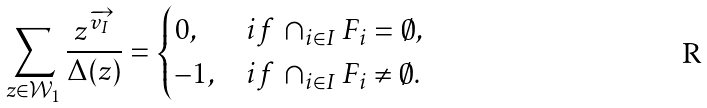Convert formula to latex. <formula><loc_0><loc_0><loc_500><loc_500>\sum _ { z \in \mathcal { W } _ { 1 } } \frac { z ^ { \overrightarrow { v _ { I } } } } { \Delta ( z ) } = \begin{cases} 0 , & i f \, \cap _ { i \in I } F _ { i } = \emptyset , \\ - 1 , & i f \, \cap _ { i \in I } F _ { i } \neq \emptyset . \end{cases}</formula> 